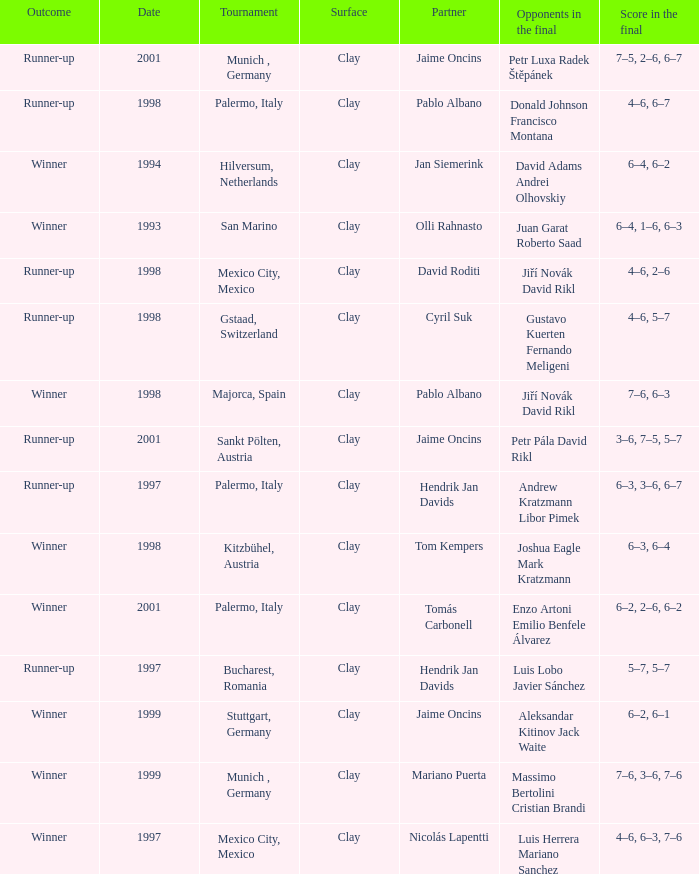Prior to 1998, who faced off in the final match of the bucharest, romania tournament? Luis Lobo Javier Sánchez. 